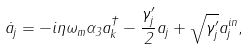<formula> <loc_0><loc_0><loc_500><loc_500>\dot { a } _ { j } = - i \eta \omega _ { m } \alpha _ { 3 } a _ { k } ^ { \dagger } - \frac { \gamma ^ { \prime } _ { j } } { 2 } a _ { j } + \sqrt { \gamma ^ { \prime } _ { j } } a _ { j } ^ { i n } ,</formula> 